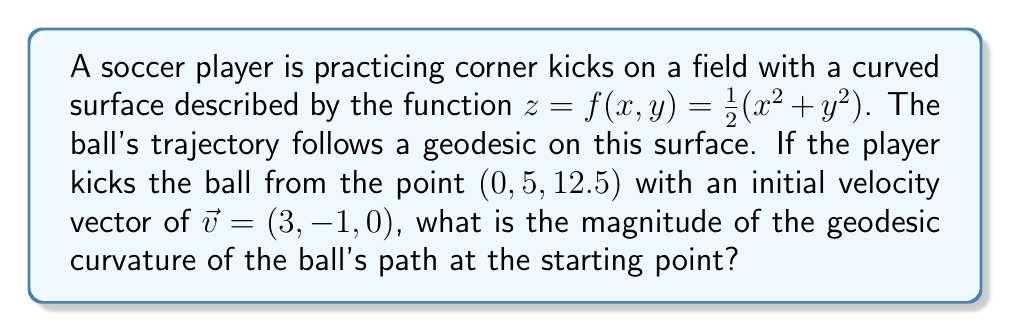Could you help me with this problem? Let's approach this step-by-step:

1) The geodesic curvature is the component of the curvature of a curve on a surface that is perpendicular to the surface normal. For a geodesic, this curvature is zero.

2) To find the geodesic curvature, we need to calculate:
   a) The surface normal
   b) The curvature vector of the trajectory
   c) The component of the curvature vector perpendicular to the surface normal

3) Surface normal:
   $\vec{N} = \frac{\nabla f}{|\nabla f|}$ where $\nabla f = (f_x, f_y, -1)$
   $f_x = x$, $f_y = y$
   At (0, 5, 12.5), $\nabla f = (0, 5, -1)$
   $\vec{N} = \frac{(0, 5, -1)}{\sqrt{0^2 + 5^2 + (-1)^2}} = (0, \frac{5}{\sqrt{26}}, -\frac{1}{\sqrt{26}})$

4) Curvature vector:
   For a curve $\gamma(t) = (x(t), y(t), z(t))$, the curvature vector is:
   $\vec{\kappa} = \frac{\gamma'' - (\gamma'' \cdot T)T}{|\gamma'|^2}$
   where $T = \frac{\gamma'}{|\gamma'|}$ is the unit tangent vector

5) At the starting point:
   $\gamma'(0) = (3, -1, 0)$
   $|\gamma'(0)| = \sqrt{3^2 + (-1)^2 + 0^2} = \sqrt{10}$
   $T = (\frac{3}{\sqrt{10}}, -\frac{1}{\sqrt{10}}, 0)$

6) To find $\gamma''(0)$, we need the geodesic equation, which is complex for this surface. However, we know that for a geodesic, the component of $\gamma''$ perpendicular to the surface is given by:
   $(\gamma'' \cdot N)N = ((\gamma' \cdot \nabla)(\gamma' \cdot \nabla f))N$

7) Calculating:
   $\gamma' \cdot \nabla f = 3(0) + (-1)(5) + 0(-1) = -5$
   $(\gamma' \cdot \nabla)(\gamma' \cdot \nabla f) = 3(0) + (-1)(5) + 0(0) = -5$

8) Therefore:
   $\gamma''(0) = -5N = (-0, -\frac{25}{\sqrt{26}}, \frac{5}{\sqrt{26}})$

9) The geodesic curvature is the magnitude of the component of $\vec{\kappa}$ perpendicular to $N$:
   $\kappa_g = |\vec{\kappa} - (\vec{\kappa} \cdot N)N|$

10) For a geodesic, $\kappa_g = 0$
Answer: 0 